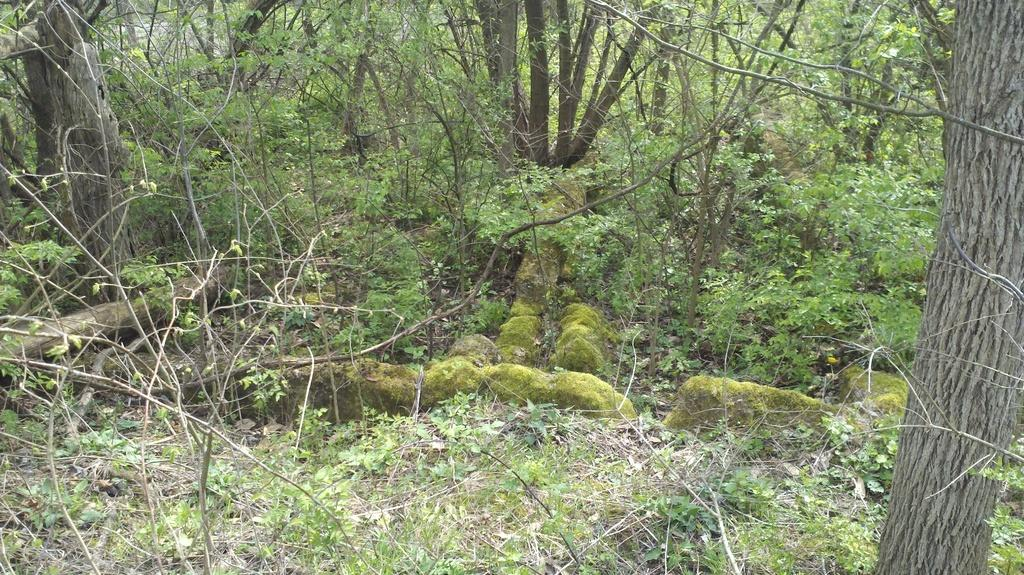What type of vegetation can be seen in the image? There are trees in the image. What type of riddle can be found in the cemetery near the ocean in the image? There is no riddle, cemetery, or ocean present in the image; it only features trees. 